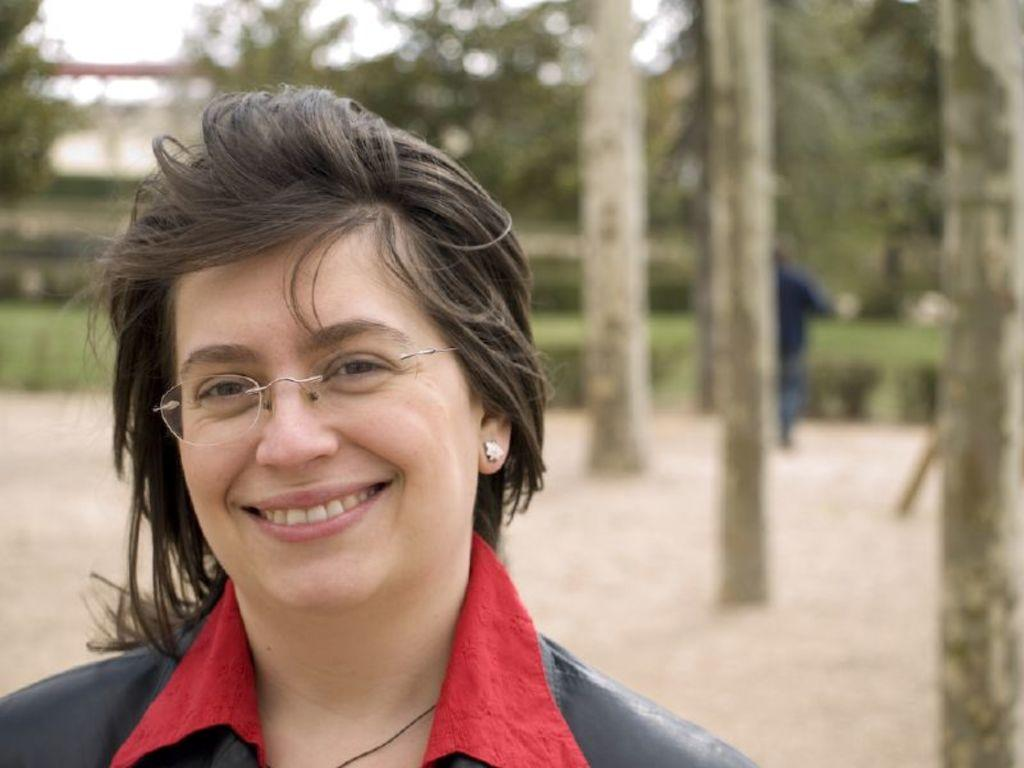What is the main subject of the image? There is a person standing in the image. Can you describe the person's attire? The person is wearing a black and red color dress. Are there any other people visible in the image? Yes, there are other persons standing in the background of the image. What type of vegetation can be seen in the background? There are trees with green color in the background of the image. What is the color of the sky in the image? The sky is visible in the background of the image, and it appears to be white in color. What type of fireman is washing the car in the image? There is no fireman or car present in the image. 